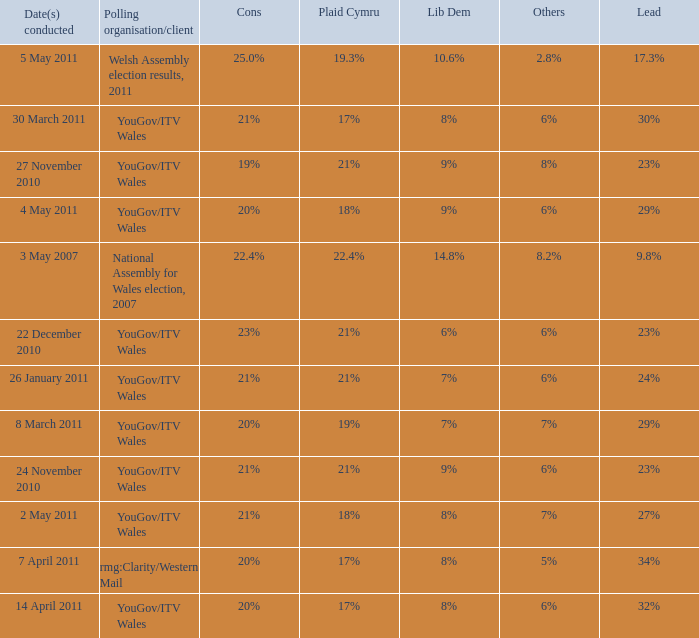Name the others for cons of 21% and lead of 24% 6%. 